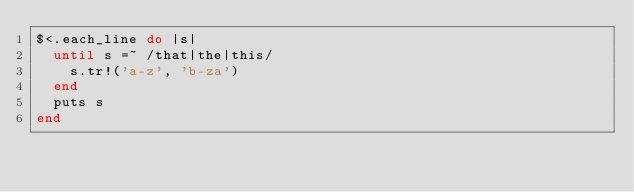Convert code to text. <code><loc_0><loc_0><loc_500><loc_500><_Ruby_>$<.each_line do |s|
  until s =~ /that|the|this/
    s.tr!('a-z', 'b-za')
  end
  puts s
end</code> 